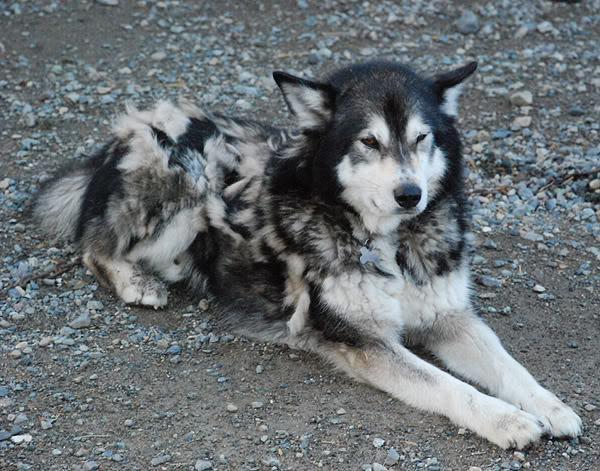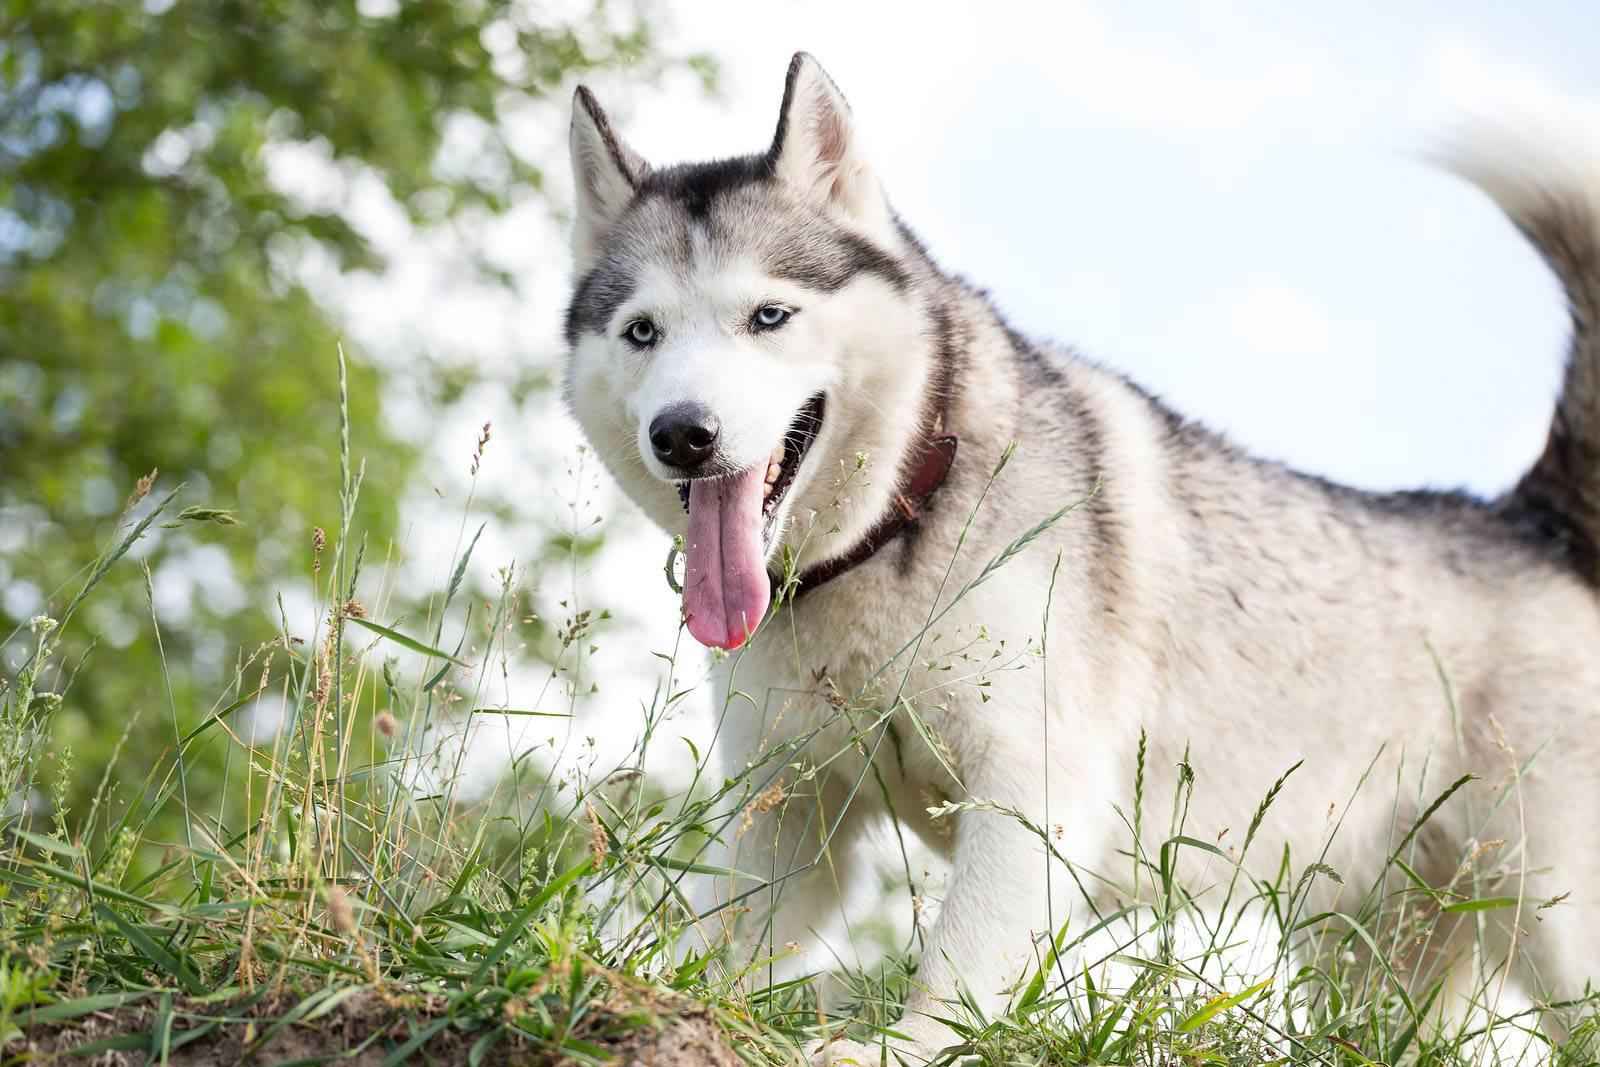The first image is the image on the left, the second image is the image on the right. For the images shown, is this caption "There is freshly cut hair on the ground." true? Answer yes or no. No. The first image is the image on the left, the second image is the image on the right. Analyze the images presented: Is the assertion "Four or more dogs can be seen." valid? Answer yes or no. No. 